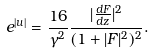<formula> <loc_0><loc_0><loc_500><loc_500>e ^ { | u | } = \frac { 1 6 } { \gamma ^ { 2 } } \frac { | \frac { d F } { d z } | ^ { 2 } } { ( 1 + | F | ^ { 2 } ) ^ { 2 } } .</formula> 